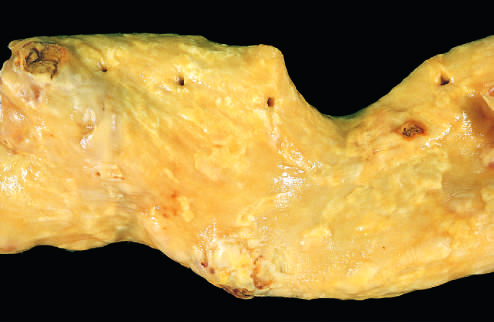what is aorta with mild atherosclerosis composed of?
Answer the question using a single word or phrase. Fibrous plaques 